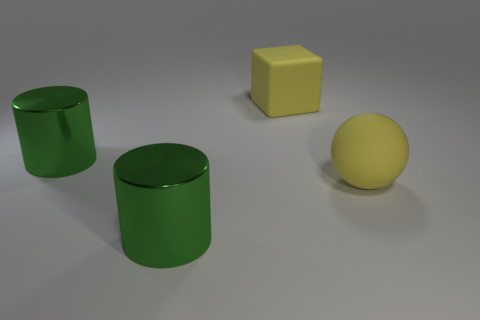Add 3 brown metallic balls. How many objects exist? 7 Subtract all spheres. How many objects are left? 3 Add 3 metal objects. How many metal objects are left? 5 Add 4 large green metal objects. How many large green metal objects exist? 6 Subtract 0 gray spheres. How many objects are left? 4 Subtract all yellow rubber cylinders. Subtract all rubber blocks. How many objects are left? 3 